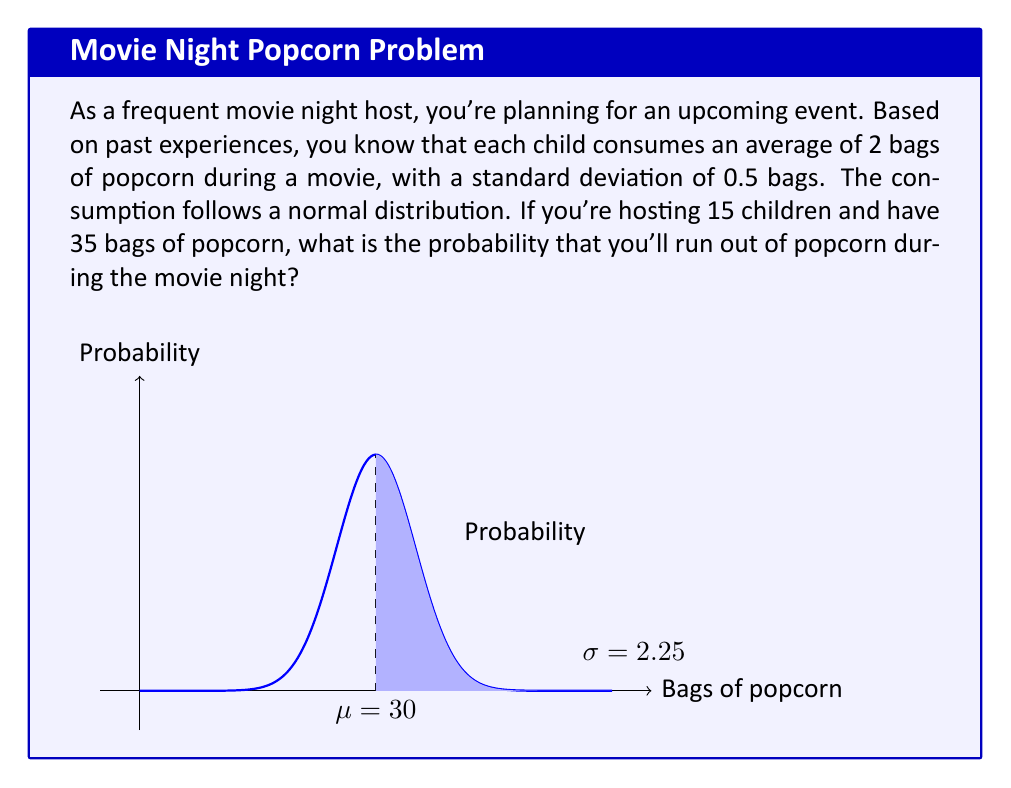Teach me how to tackle this problem. Let's approach this step-by-step:

1) First, we need to calculate the mean and standard deviation of total popcorn consumption:

   Mean (μ) = 15 children × 2 bags/child = 30 bags
   Standard deviation (σ) = $\sqrt{15} \times 0.5 = 2.25$ bags

   (We use $\sqrt{15}$ because the variances add for independent events)

2) We have 35 bags available. We want to find the probability of consuming more than 35 bags.

3) To standardize this, we calculate the z-score:

   $z = \frac{x - \mu}{\sigma} = \frac{35 - 30}{2.25} = 2.22$

4) Now, we need to find P(Z > 2.22), where Z is a standard normal variable.

5) Using a standard normal table or calculator, we can find that:

   P(Z < 2.22) ≈ 0.9868

6) Therefore, P(Z > 2.22) = 1 - P(Z < 2.22) = 1 - 0.9868 = 0.0132

Thus, there's approximately a 1.32% chance of running out of popcorn.
Answer: 0.0132 or 1.32% 